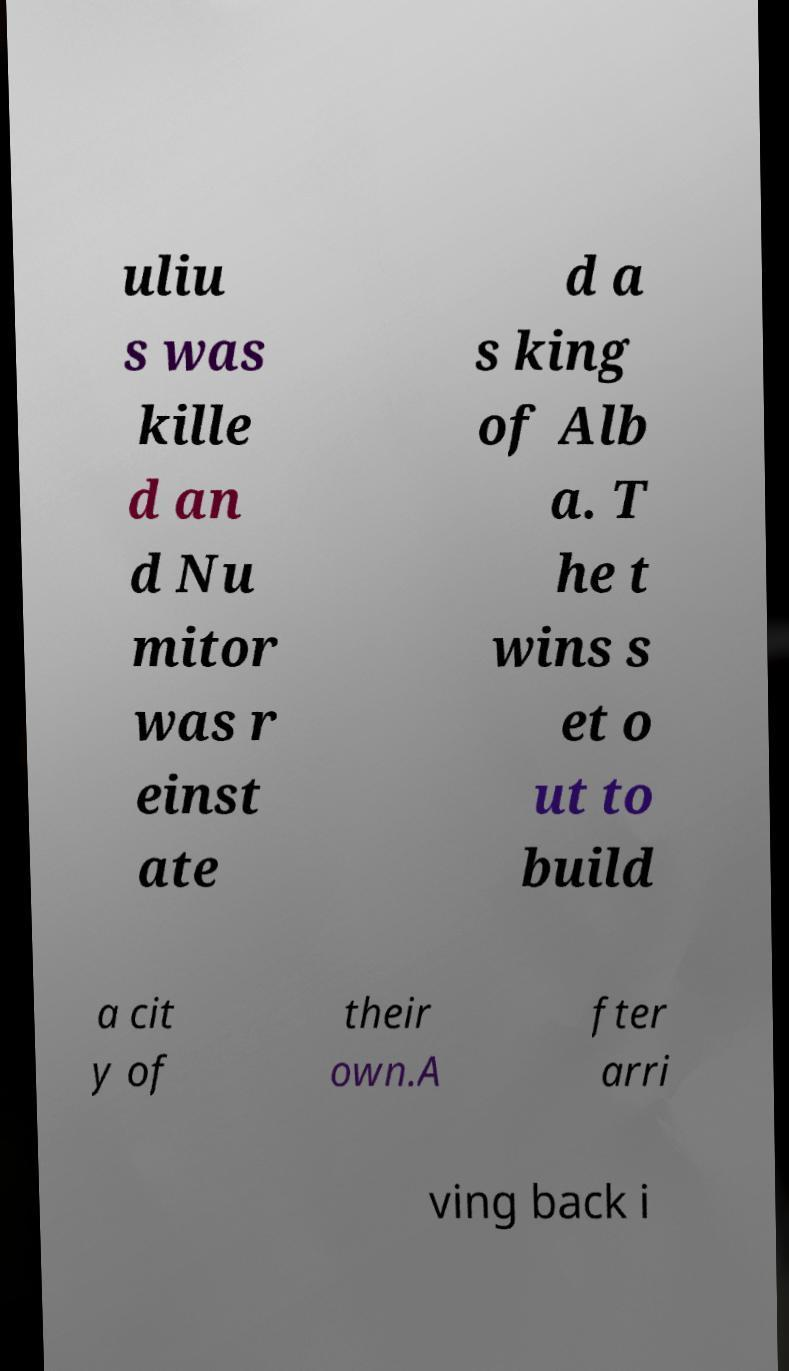Please identify and transcribe the text found in this image. uliu s was kille d an d Nu mitor was r einst ate d a s king of Alb a. T he t wins s et o ut to build a cit y of their own.A fter arri ving back i 